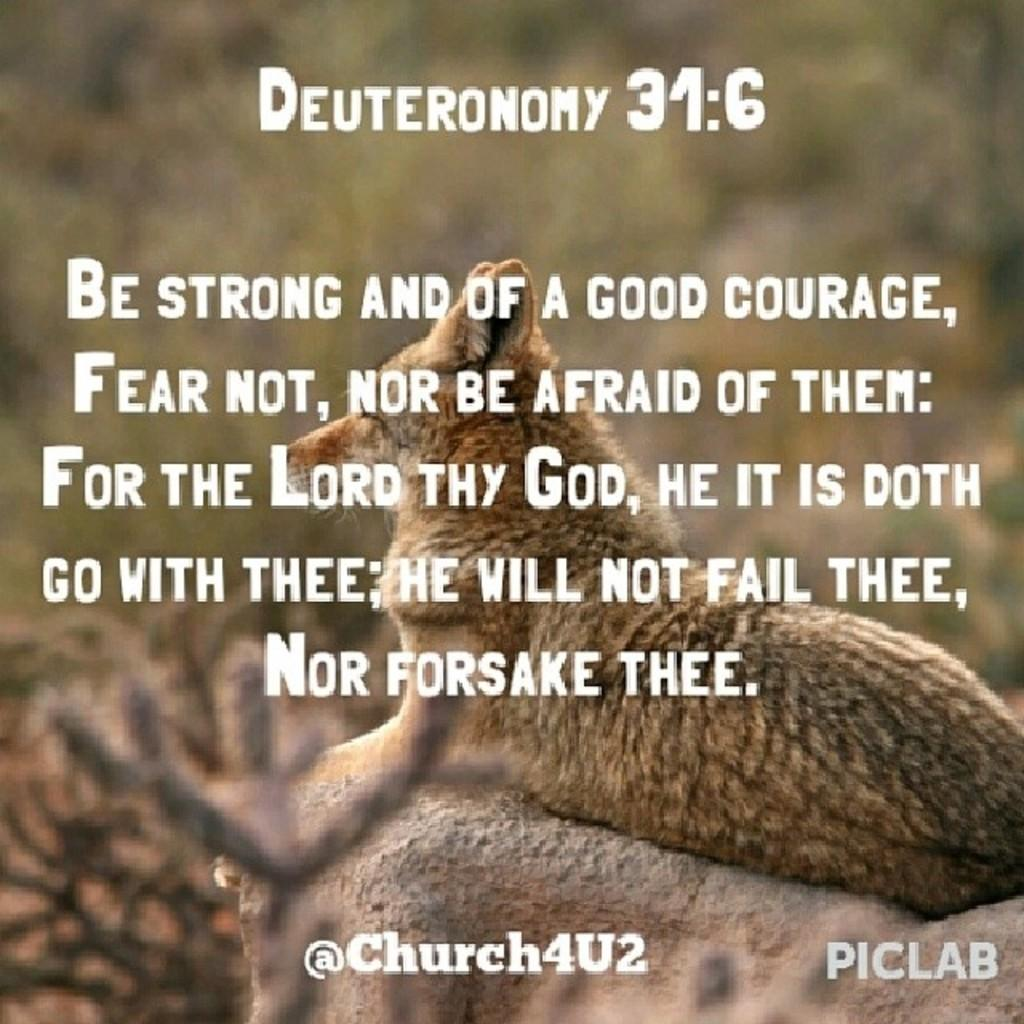What type of text can be seen in the image? There is edited text in the image. What is the animal sitting on in the image? The animal is sitting on the rocks in the image. How would you describe the background of the image? The background of the image is blurred. What statement does the grandfather make in the image? There is no grandfather present in the image, so no statement can be attributed to him. What does the animal need in the image? The image does not provide information about the animal's needs, as it only shows the animal sitting on the rocks. 